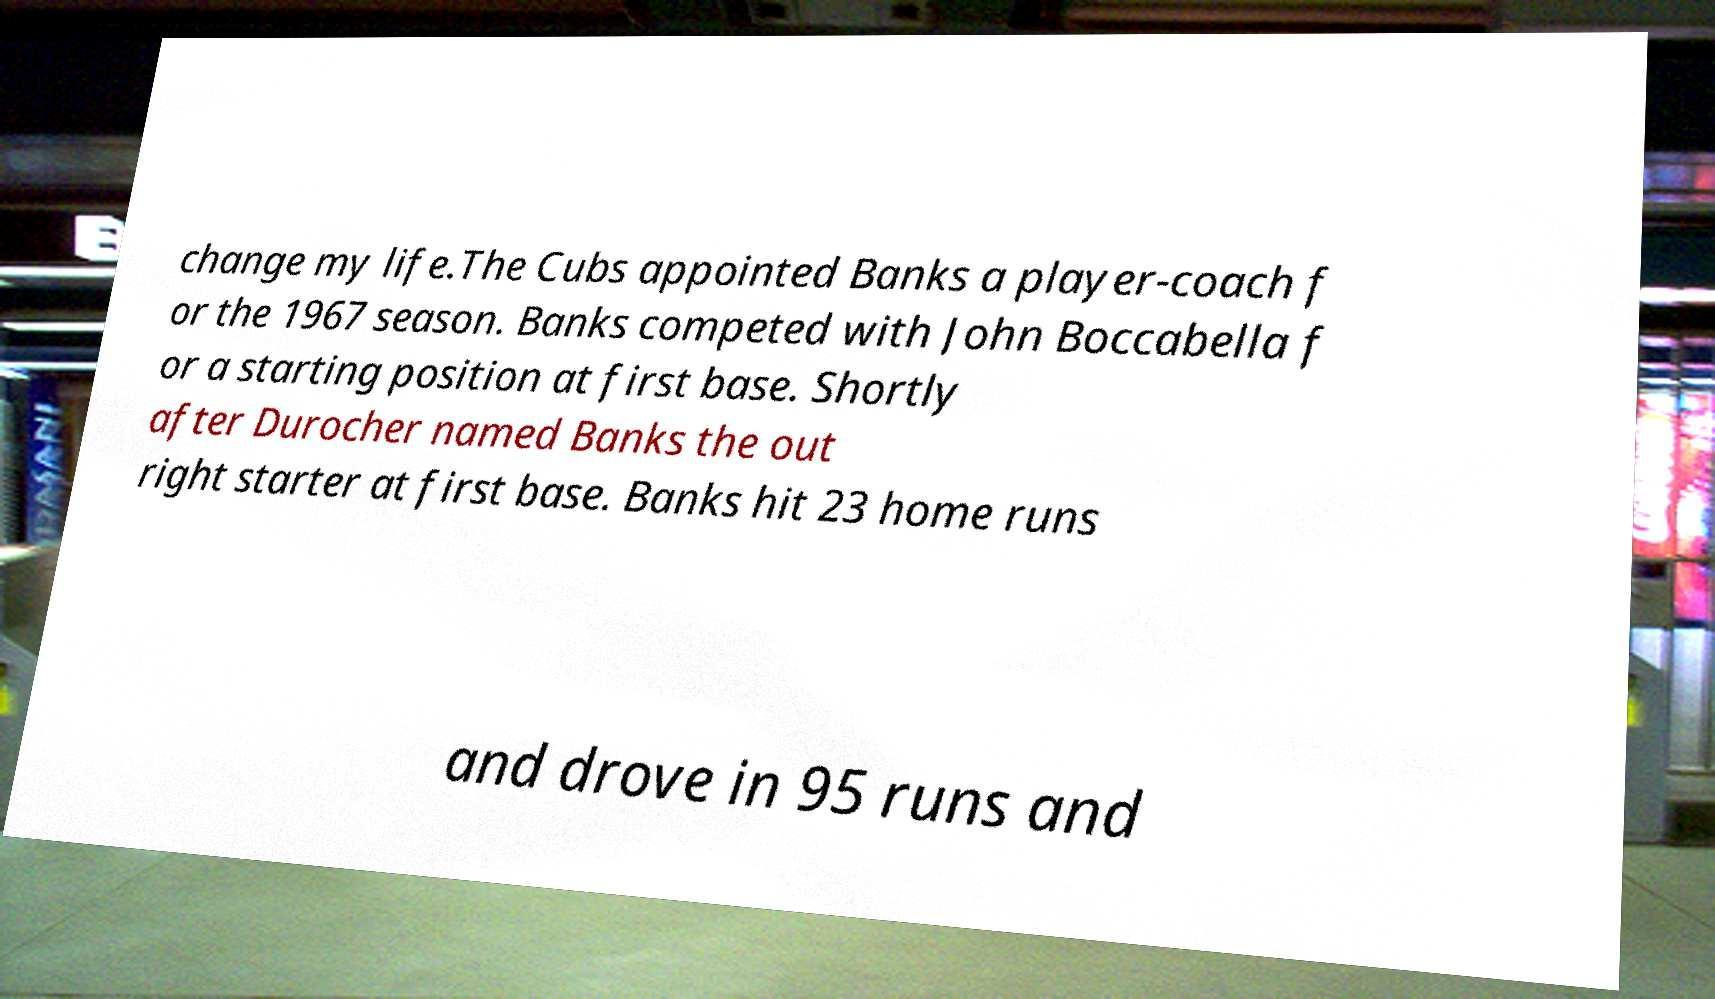Please read and relay the text visible in this image. What does it say? change my life.The Cubs appointed Banks a player-coach f or the 1967 season. Banks competed with John Boccabella f or a starting position at first base. Shortly after Durocher named Banks the out right starter at first base. Banks hit 23 home runs and drove in 95 runs and 